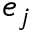Convert formula to latex. <formula><loc_0><loc_0><loc_500><loc_500>e _ { j }</formula> 